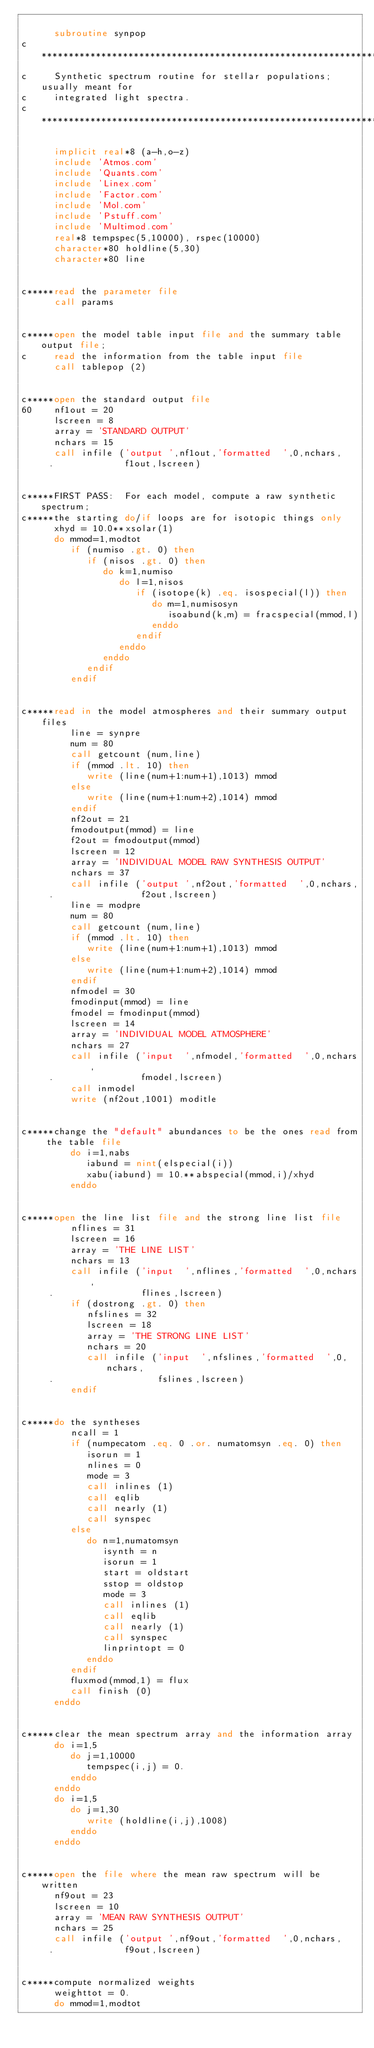Convert code to text. <code><loc_0><loc_0><loc_500><loc_500><_FORTRAN_>
      subroutine synpop
c******************************************************************************
c     Synthetic spectrum routine for stellar populations; usually meant for
c     integrated light spectra.
c******************************************************************************

      implicit real*8 (a-h,o-z)
      include 'Atmos.com'
      include 'Quants.com'
      include 'Linex.com'
      include 'Factor.com'
      include 'Mol.com'
      include 'Pstuff.com'
      include 'Multimod.com'
      real*8 tempspec(5,10000), rspec(10000)
      character*80 holdline(5,30)
      character*80 line


c*****read the parameter file
      call params


c*****open the model table input file and the summary table output file;
c     read the information from the table input file
      call tablepop (2)


c*****open the standard output file
60    nf1out = 20
      lscreen = 8
      array = 'STANDARD OUTPUT'
      nchars = 15
      call infile ('output ',nf1out,'formatted  ',0,nchars,
     .             f1out,lscreen)


c*****FIRST PASS:  For each model, compute a raw synthetic spectrum;
c*****the starting do/if loops are for isotopic things only
      xhyd = 10.0**xsolar(1)
      do mmod=1,modtot
         if (numiso .gt. 0) then
            if (nisos .gt. 0) then
               do k=1,numiso
                  do l=1,nisos
                     if (isotope(k) .eq. isospecial(l)) then
                        do m=1,numisosyn
                           isoabund(k,m) = fracspecial(mmod,l)
                        enddo
                     endif
                  enddo
               enddo
            endif
         endif


c*****read in the model atmospheres and their summary output files
         line = synpre
         num = 80
         call getcount (num,line)
         if (mmod .lt. 10) then
            write (line(num+1:num+1),1013) mmod
         else
            write (line(num+1:num+2),1014) mmod
         endif
         nf2out = 21
         fmodoutput(mmod) = line
         f2out = fmodoutput(mmod)
         lscreen = 12
         array = 'INDIVIDUAL MODEL RAW SYNTHESIS OUTPUT'
         nchars = 37
         call infile ('output ',nf2out,'formatted  ',0,nchars,
     .                f2out,lscreen)
         line = modpre
         num = 80
         call getcount (num,line)
         if (mmod .lt. 10) then
            write (line(num+1:num+1),1013) mmod
         else
            write (line(num+1:num+2),1014) mmod
         endif
         nfmodel = 30
         fmodinput(mmod) = line
         fmodel = fmodinput(mmod)
         lscreen = 14
         array = 'INDIVIDUAL MODEL ATMOSPHERE'
         nchars = 27
         call infile ('input  ',nfmodel,'formatted  ',0,nchars,
     .                fmodel,lscreen)
         call inmodel
         write (nf2out,1001) moditle


c*****change the "default" abundances to be the ones read from the table file
         do i=1,nabs
            iabund = nint(elspecial(i))
            xabu(iabund) = 10.**abspecial(mmod,i)/xhyd
         enddo


c*****open the line list file and the strong line list file
         nflines = 31
         lscreen = 16
         array = 'THE LINE LIST'
         nchars = 13
         call infile ('input  ',nflines,'formatted  ',0,nchars,
     .                flines,lscreen)
         if (dostrong .gt. 0) then
            nfslines = 32
            lscreen = 18
            array = 'THE STRONG LINE LIST'
            nchars = 20
            call infile ('input  ',nfslines,'formatted  ',0,nchars,
     .                   fslines,lscreen)
         endif


c*****do the syntheses
         ncall = 1
         if (numpecatom .eq. 0 .or. numatomsyn .eq. 0) then
            isorun = 1
            nlines = 0
            mode = 3
            call inlines (1)
            call eqlib
            call nearly (1)
            call synspec
         else
            do n=1,numatomsyn
               isynth = n
               isorun = 1
               start = oldstart
               sstop = oldstop
               mode = 3
               call inlines (1)
               call eqlib
               call nearly (1)
               call synspec
               linprintopt = 0
            enddo
         endif
         fluxmod(mmod,1) = flux
         call finish (0)
      enddo


c*****clear the mean spectrum array and the information array
      do i=1,5
         do j=1,10000
            tempspec(i,j) = 0.
         enddo
      enddo
      do i=1,5
         do j=1,30
            write (holdline(i,j),1008)
         enddo
      enddo


c*****open the file where the mean raw spectrum will be written
      nf9out = 23
      lscreen = 10
      array = 'MEAN RAW SYNTHESIS OUTPUT'
      nchars = 25
      call infile ('output ',nf9out,'formatted  ',0,nchars,
     .             f9out,lscreen)


c*****compute normalized weights
      weighttot = 0.
      do mmod=1,modtot</code> 